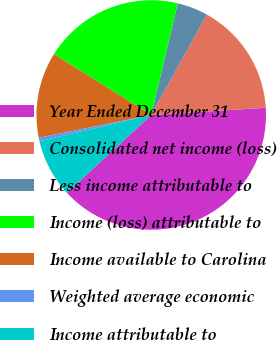<chart> <loc_0><loc_0><loc_500><loc_500><pie_chart><fcel>Year Ended December 31<fcel>Consolidated net income (loss)<fcel>Less income attributable to<fcel>Income (loss) attributable to<fcel>Income available to Carolina<fcel>Weighted average economic<fcel>Income attributable to<nl><fcel>39.14%<fcel>15.94%<fcel>4.35%<fcel>19.81%<fcel>12.08%<fcel>0.48%<fcel>8.21%<nl></chart> 